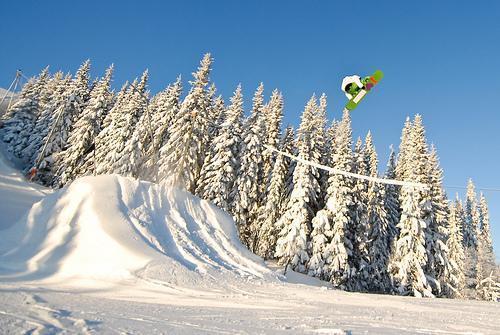How many people are in this picture?
Give a very brief answer. 1. 